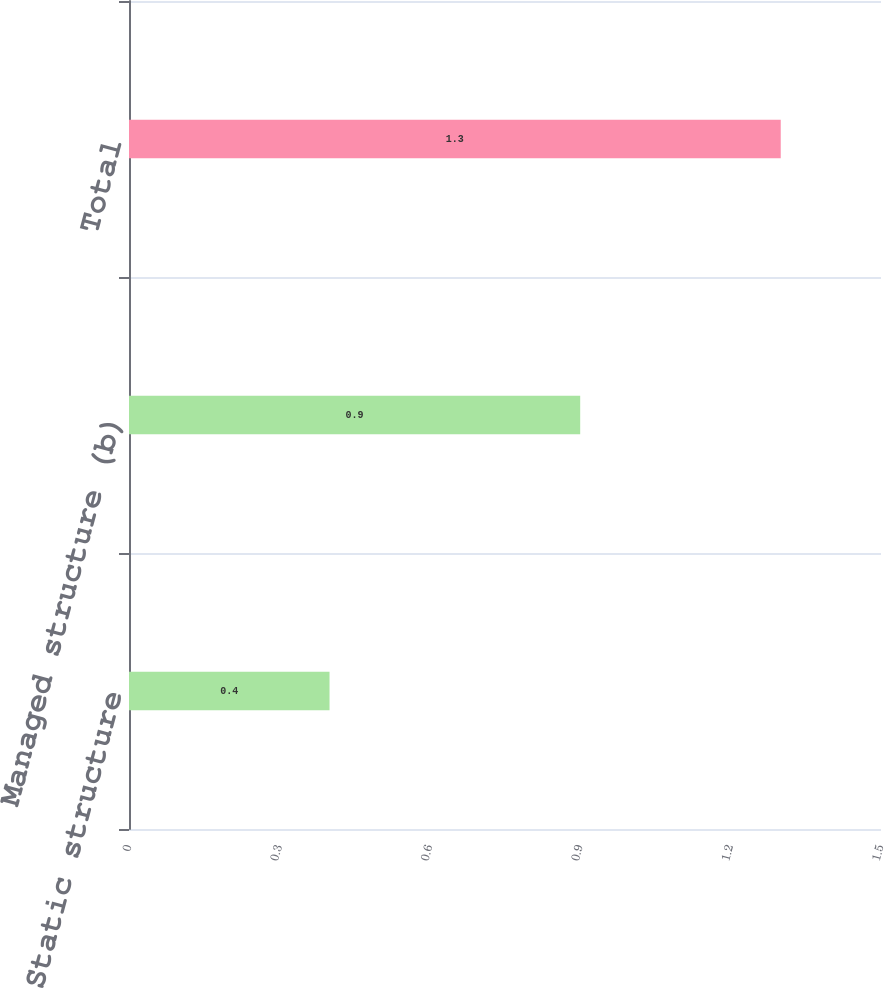Convert chart. <chart><loc_0><loc_0><loc_500><loc_500><bar_chart><fcel>Static structure<fcel>Managed structure (b)<fcel>Total<nl><fcel>0.4<fcel>0.9<fcel>1.3<nl></chart> 